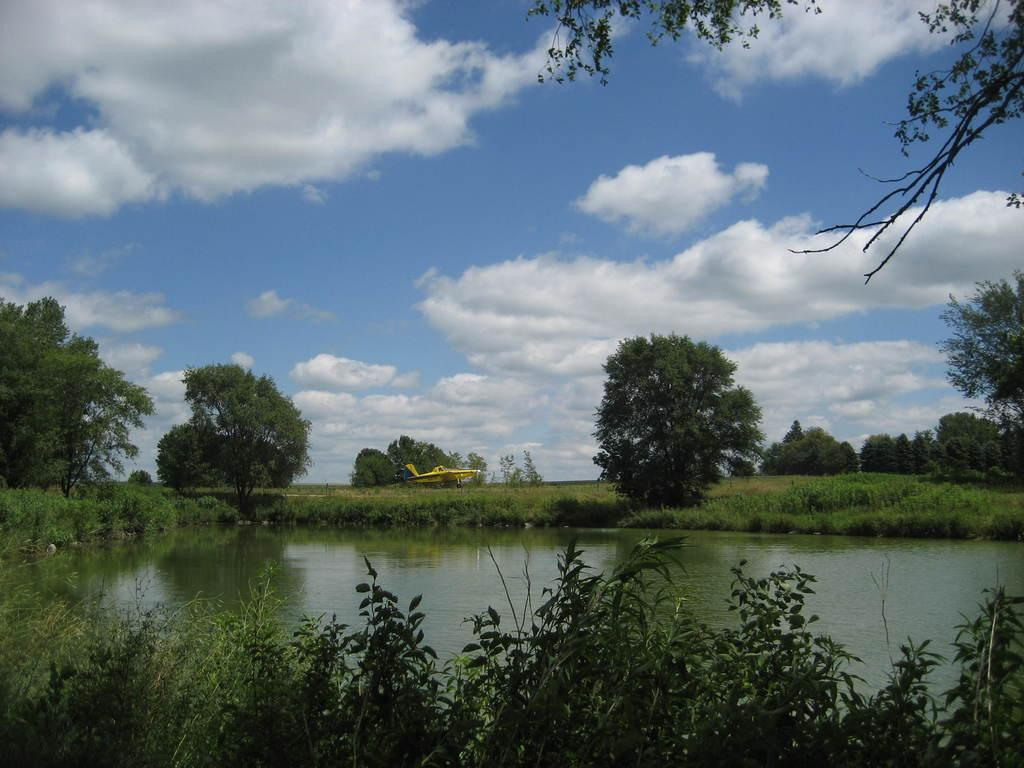What type of body of water is present in the image? There is a small lake in the picture. What type of vegetation can be seen in the image? There is grass, plants, and trees in the picture. What is the condition of the sky in the image? The sky is clear in the picture. What unrelated object can be seen in the image? There is an airplane in the picture. What type of insurance is being sold near the small lake in the image? There is no indication of insurance being sold or advertised in the image. How many bikes are visible in the image? There are no bikes present in the image. 